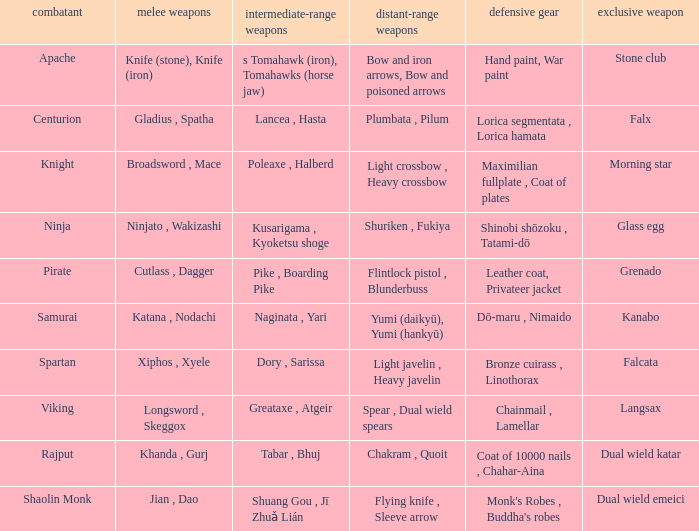If the special weapon is glass egg, what is the close ranged weapon? Ninjato , Wakizashi. 